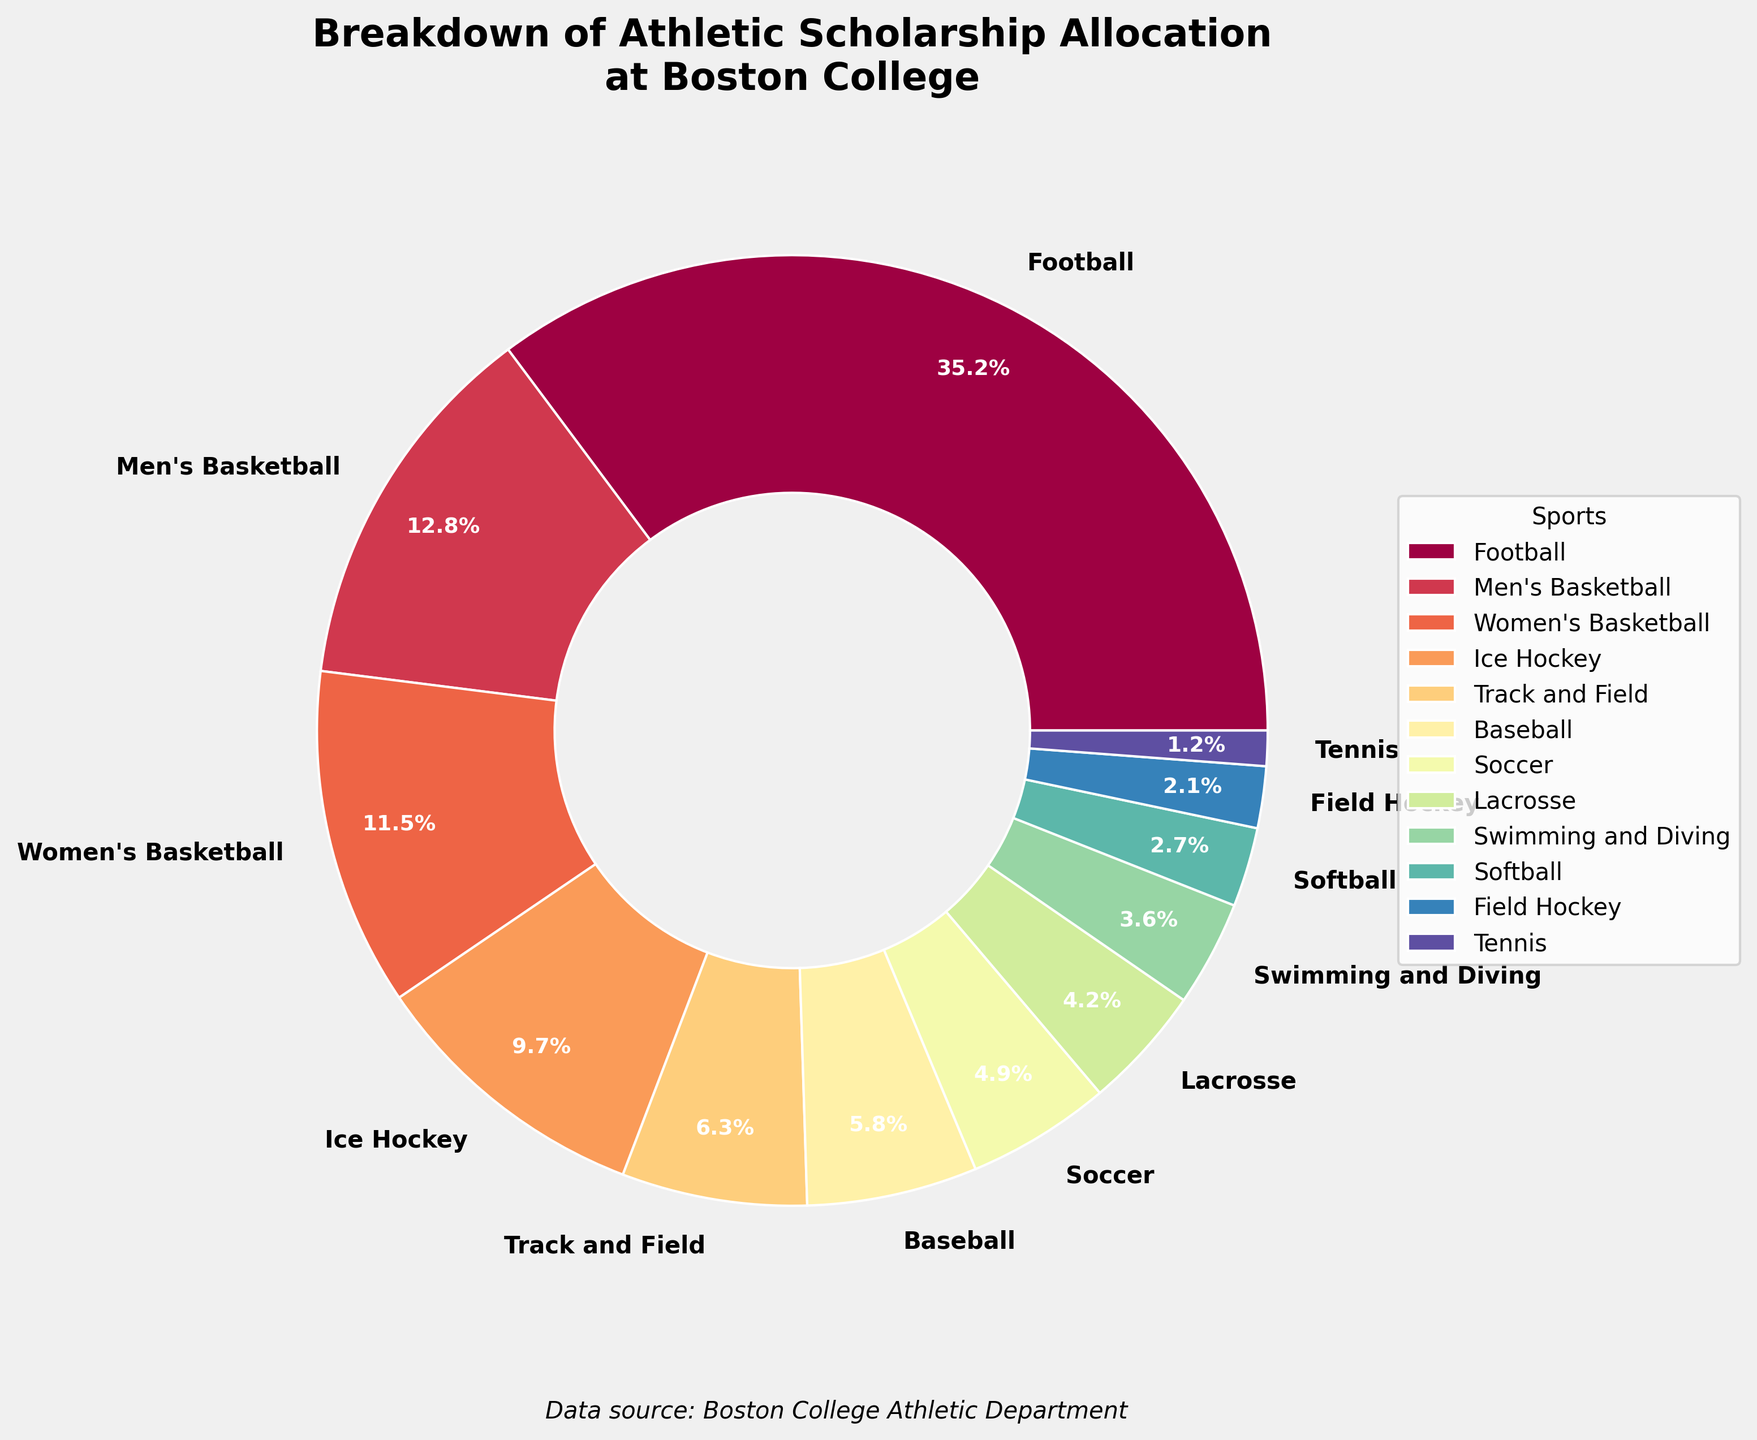What sport receives the highest percentage of athletic scholarships? The sport receiving the highest percentage of athletic scholarships is the one with the largest slice in the pie chart. In the figure, this is Football.
Answer: Football Which sport has a higher scholarship allocation percentage, Men's Basketball or Women's Basketball? Compare the percentages of scholarship allocation for both Men's Basketball and Women's Basketball. According to the figure, Men's Basketball has 12.8%, and Women's Basketball has 11.5%. Therefore, Men's Basketball has a higher percentage.
Answer: Men's Basketball What is the combined scholarship allocation percentage for both Football and Men's Basketball? Add the percentages for Football and Men's Basketball. Football has 35.2% and Men's Basketball has 12.8%. So, the combined percentage is 35.2 + 12.8 = 48%.
Answer: 48% Which sport has the smallest scholarship allocation percentage? The sport with the smallest slice in the pie chart represents the smallest scholarship allocation percentage. In this case, it is Tennis with 1.2%.
Answer: Tennis Are there more funds allocated to Ice Hockey or both Swimming and Diving and Softball combined? Compare the scholarship allocation for Ice Hockey to the combined percentage for Swimming and Diving and Softball. Ice Hockey is 9.7%, Swimming and Diving is 3.6%, and Softball is 2.7%. So, combined Swimming and Diving, and Softball is 3.6 + 2.7 = 6.3%, which is less than 9.7%.
Answer: Ice Hockey How many sports have a scholarship allocation percentage of 5% or higher? Count the number of sports in the figure that have a slice representing 5% or higher. These sports are Football (35.2%), Men's Basketball (12.8%), Women's Basketball (11.5%), and Ice Hockey (9.7%), Track and Field (6.3%), and Baseball (5.8%). There are 6 such sports.
Answer: 6 What's the difference in scholarship allocation between Lacrosse and Soccer? Subtract the scholarship allocation percentage of Lacrosse from that of Soccer. Soccer has 4.9% and Lacrosse has 4.2%. So, the difference is 4.9 - 4.2 = 0.7%.
Answer: 0.7% What is the average scholarship allocation percentage for the sports with the three highest allocations? Identify the three sports with the highest allocations and then calculate their average. These sports are Football (35.2%), Men's Basketball (12.8%), and Women's Basketball (11.5%). The average is (35.2 + 12.8 + 11.5) / 3 = 19.833%.
Answer: 19.8% (rounded to one decimal place) What percentage of the total scholarship allocation is given to sports other than Football? Subtract the scholarship allocation for Football from 100%. Football receives 35.2%, so the percentage for all other sports combined is 100 - 35.2 = 64.8%.
Answer: 64.8% Are there any sports that receive an equal or lower percentage of scholarships compared to Field Hockey? Identify percentages equal to or smaller than that of Field Hockey. Field Hockey has 2.1%. Only Tennis has an equal or lower percentage, with 1.2%.
Answer: Yes, Tennis 